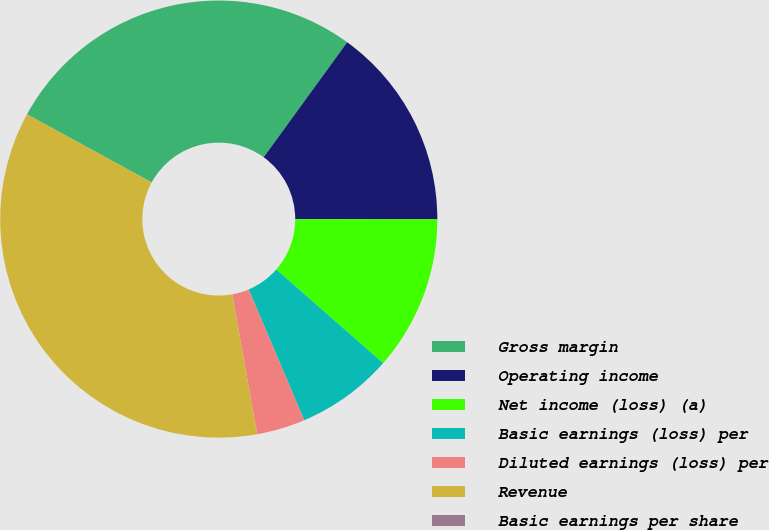Convert chart to OTSL. <chart><loc_0><loc_0><loc_500><loc_500><pie_chart><fcel>Gross margin<fcel>Operating income<fcel>Net income (loss) (a)<fcel>Basic earnings (loss) per<fcel>Diluted earnings (loss) per<fcel>Revenue<fcel>Basic earnings per share<nl><fcel>27.04%<fcel>15.02%<fcel>11.44%<fcel>7.15%<fcel>3.58%<fcel>35.77%<fcel>0.0%<nl></chart> 